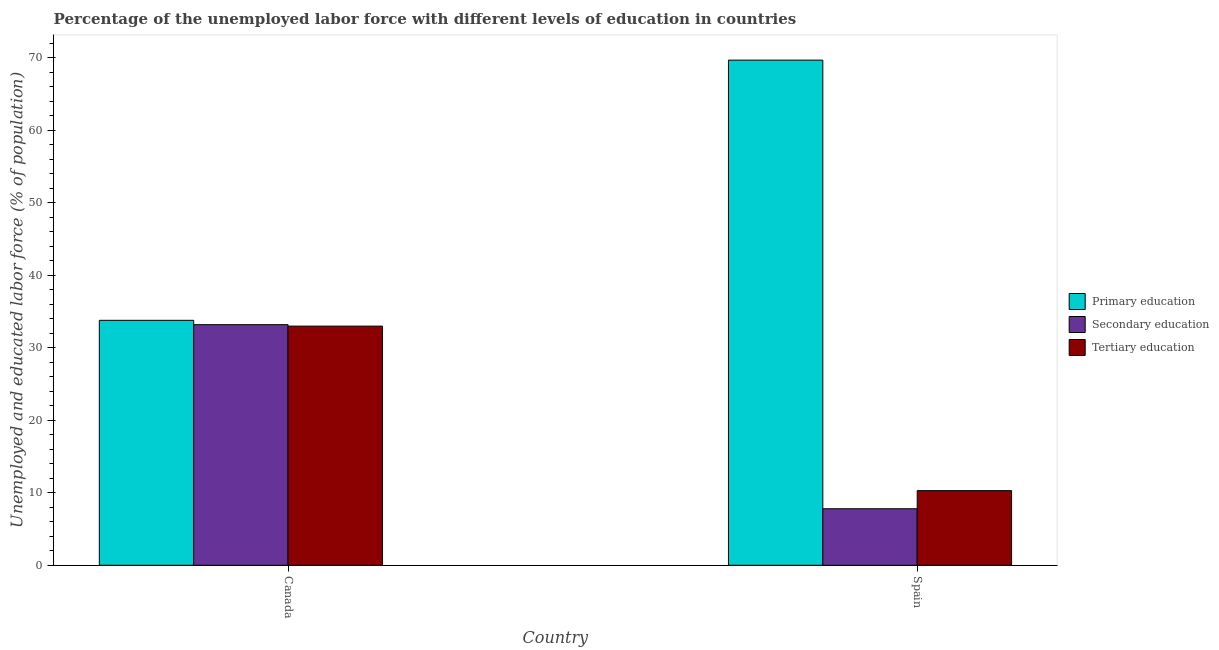Are the number of bars per tick equal to the number of legend labels?
Keep it short and to the point. Yes. Are the number of bars on each tick of the X-axis equal?
Offer a terse response. Yes. What is the label of the 1st group of bars from the left?
Make the answer very short. Canada. In how many cases, is the number of bars for a given country not equal to the number of legend labels?
Your answer should be very brief. 0. What is the percentage of labor force who received secondary education in Canada?
Ensure brevity in your answer.  33.2. Across all countries, what is the maximum percentage of labor force who received primary education?
Your answer should be very brief. 69.7. Across all countries, what is the minimum percentage of labor force who received tertiary education?
Your response must be concise. 10.3. What is the total percentage of labor force who received secondary education in the graph?
Offer a terse response. 41. What is the difference between the percentage of labor force who received primary education in Canada and that in Spain?
Offer a very short reply. -35.9. What is the difference between the percentage of labor force who received primary education in Canada and the percentage of labor force who received tertiary education in Spain?
Ensure brevity in your answer.  23.5. What is the average percentage of labor force who received tertiary education per country?
Offer a very short reply. 21.65. What is the difference between the percentage of labor force who received secondary education and percentage of labor force who received primary education in Spain?
Ensure brevity in your answer.  -61.9. In how many countries, is the percentage of labor force who received primary education greater than 2 %?
Provide a short and direct response. 2. What is the ratio of the percentage of labor force who received secondary education in Canada to that in Spain?
Provide a short and direct response. 4.26. In how many countries, is the percentage of labor force who received secondary education greater than the average percentage of labor force who received secondary education taken over all countries?
Make the answer very short. 1. What does the 1st bar from the left in Spain represents?
Offer a very short reply. Primary education. What does the 3rd bar from the right in Spain represents?
Offer a terse response. Primary education. Is it the case that in every country, the sum of the percentage of labor force who received primary education and percentage of labor force who received secondary education is greater than the percentage of labor force who received tertiary education?
Your answer should be compact. Yes. How many bars are there?
Provide a succinct answer. 6. Are all the bars in the graph horizontal?
Give a very brief answer. No. Are the values on the major ticks of Y-axis written in scientific E-notation?
Make the answer very short. No. Does the graph contain any zero values?
Provide a succinct answer. No. Does the graph contain grids?
Provide a succinct answer. No. Where does the legend appear in the graph?
Offer a very short reply. Center right. How many legend labels are there?
Keep it short and to the point. 3. What is the title of the graph?
Your answer should be very brief. Percentage of the unemployed labor force with different levels of education in countries. What is the label or title of the X-axis?
Provide a short and direct response. Country. What is the label or title of the Y-axis?
Your answer should be compact. Unemployed and educated labor force (% of population). What is the Unemployed and educated labor force (% of population) in Primary education in Canada?
Your response must be concise. 33.8. What is the Unemployed and educated labor force (% of population) in Secondary education in Canada?
Provide a succinct answer. 33.2. What is the Unemployed and educated labor force (% of population) in Primary education in Spain?
Ensure brevity in your answer.  69.7. What is the Unemployed and educated labor force (% of population) of Secondary education in Spain?
Your response must be concise. 7.8. What is the Unemployed and educated labor force (% of population) in Tertiary education in Spain?
Your answer should be very brief. 10.3. Across all countries, what is the maximum Unemployed and educated labor force (% of population) in Primary education?
Make the answer very short. 69.7. Across all countries, what is the maximum Unemployed and educated labor force (% of population) of Secondary education?
Your answer should be very brief. 33.2. Across all countries, what is the maximum Unemployed and educated labor force (% of population) of Tertiary education?
Offer a very short reply. 33. Across all countries, what is the minimum Unemployed and educated labor force (% of population) in Primary education?
Your response must be concise. 33.8. Across all countries, what is the minimum Unemployed and educated labor force (% of population) in Secondary education?
Your answer should be very brief. 7.8. Across all countries, what is the minimum Unemployed and educated labor force (% of population) of Tertiary education?
Your answer should be very brief. 10.3. What is the total Unemployed and educated labor force (% of population) in Primary education in the graph?
Offer a terse response. 103.5. What is the total Unemployed and educated labor force (% of population) in Secondary education in the graph?
Your answer should be compact. 41. What is the total Unemployed and educated labor force (% of population) of Tertiary education in the graph?
Make the answer very short. 43.3. What is the difference between the Unemployed and educated labor force (% of population) in Primary education in Canada and that in Spain?
Make the answer very short. -35.9. What is the difference between the Unemployed and educated labor force (% of population) of Secondary education in Canada and that in Spain?
Ensure brevity in your answer.  25.4. What is the difference between the Unemployed and educated labor force (% of population) of Tertiary education in Canada and that in Spain?
Give a very brief answer. 22.7. What is the difference between the Unemployed and educated labor force (% of population) of Primary education in Canada and the Unemployed and educated labor force (% of population) of Secondary education in Spain?
Offer a very short reply. 26. What is the difference between the Unemployed and educated labor force (% of population) in Primary education in Canada and the Unemployed and educated labor force (% of population) in Tertiary education in Spain?
Your response must be concise. 23.5. What is the difference between the Unemployed and educated labor force (% of population) of Secondary education in Canada and the Unemployed and educated labor force (% of population) of Tertiary education in Spain?
Offer a very short reply. 22.9. What is the average Unemployed and educated labor force (% of population) in Primary education per country?
Your answer should be compact. 51.75. What is the average Unemployed and educated labor force (% of population) of Tertiary education per country?
Your answer should be compact. 21.65. What is the difference between the Unemployed and educated labor force (% of population) in Primary education and Unemployed and educated labor force (% of population) in Tertiary education in Canada?
Offer a terse response. 0.8. What is the difference between the Unemployed and educated labor force (% of population) of Secondary education and Unemployed and educated labor force (% of population) of Tertiary education in Canada?
Give a very brief answer. 0.2. What is the difference between the Unemployed and educated labor force (% of population) in Primary education and Unemployed and educated labor force (% of population) in Secondary education in Spain?
Your answer should be compact. 61.9. What is the difference between the Unemployed and educated labor force (% of population) in Primary education and Unemployed and educated labor force (% of population) in Tertiary education in Spain?
Offer a terse response. 59.4. What is the ratio of the Unemployed and educated labor force (% of population) in Primary education in Canada to that in Spain?
Your answer should be very brief. 0.48. What is the ratio of the Unemployed and educated labor force (% of population) in Secondary education in Canada to that in Spain?
Ensure brevity in your answer.  4.26. What is the ratio of the Unemployed and educated labor force (% of population) in Tertiary education in Canada to that in Spain?
Provide a short and direct response. 3.2. What is the difference between the highest and the second highest Unemployed and educated labor force (% of population) of Primary education?
Provide a short and direct response. 35.9. What is the difference between the highest and the second highest Unemployed and educated labor force (% of population) in Secondary education?
Ensure brevity in your answer.  25.4. What is the difference between the highest and the second highest Unemployed and educated labor force (% of population) of Tertiary education?
Ensure brevity in your answer.  22.7. What is the difference between the highest and the lowest Unemployed and educated labor force (% of population) in Primary education?
Offer a terse response. 35.9. What is the difference between the highest and the lowest Unemployed and educated labor force (% of population) of Secondary education?
Give a very brief answer. 25.4. What is the difference between the highest and the lowest Unemployed and educated labor force (% of population) of Tertiary education?
Offer a terse response. 22.7. 